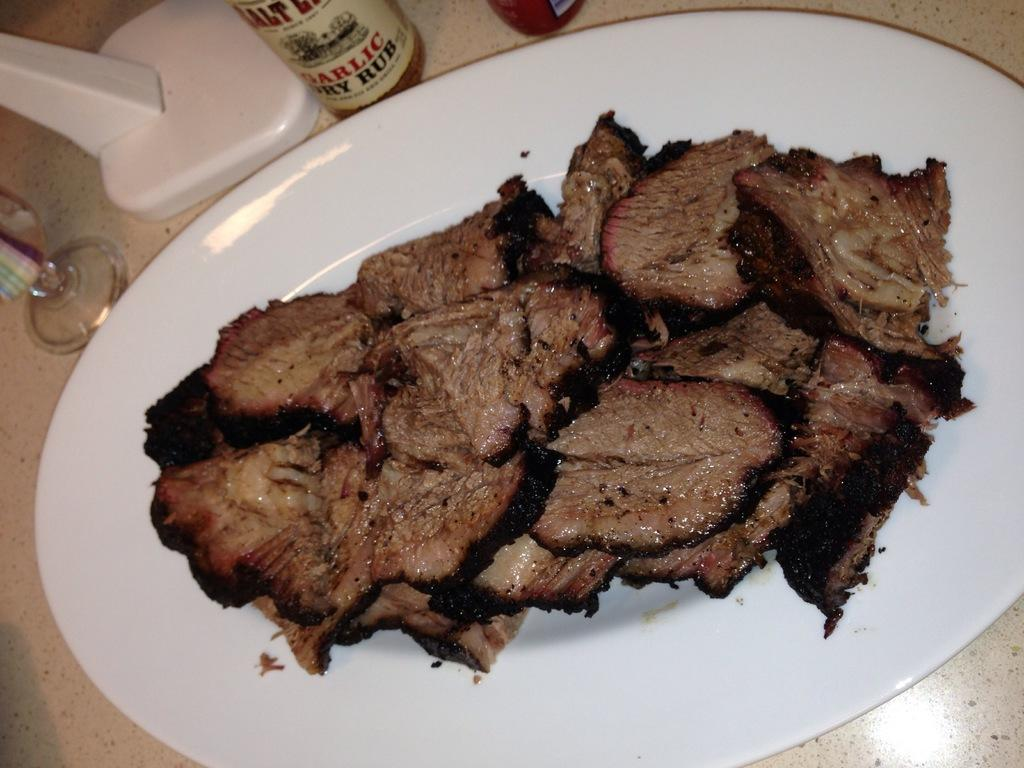What type of food is visible in the image? There are meat pieces in the image. What is the meat placed on? The meat pieces are on a white plate. What condiment-related object can be seen in the image? There is a sauce bottle in the image. What beverage-related object is present in the image? There is a water glass in the image. What type of yoke is used to hold the meat pieces in the image? There is no yoke present in the image; the meat pieces are on a white plate. What metal object can be seen in the image? There is no metal object mentioned in the provided facts; the image only includes meat pieces, a white plate, a sauce bottle, and a water glass. 